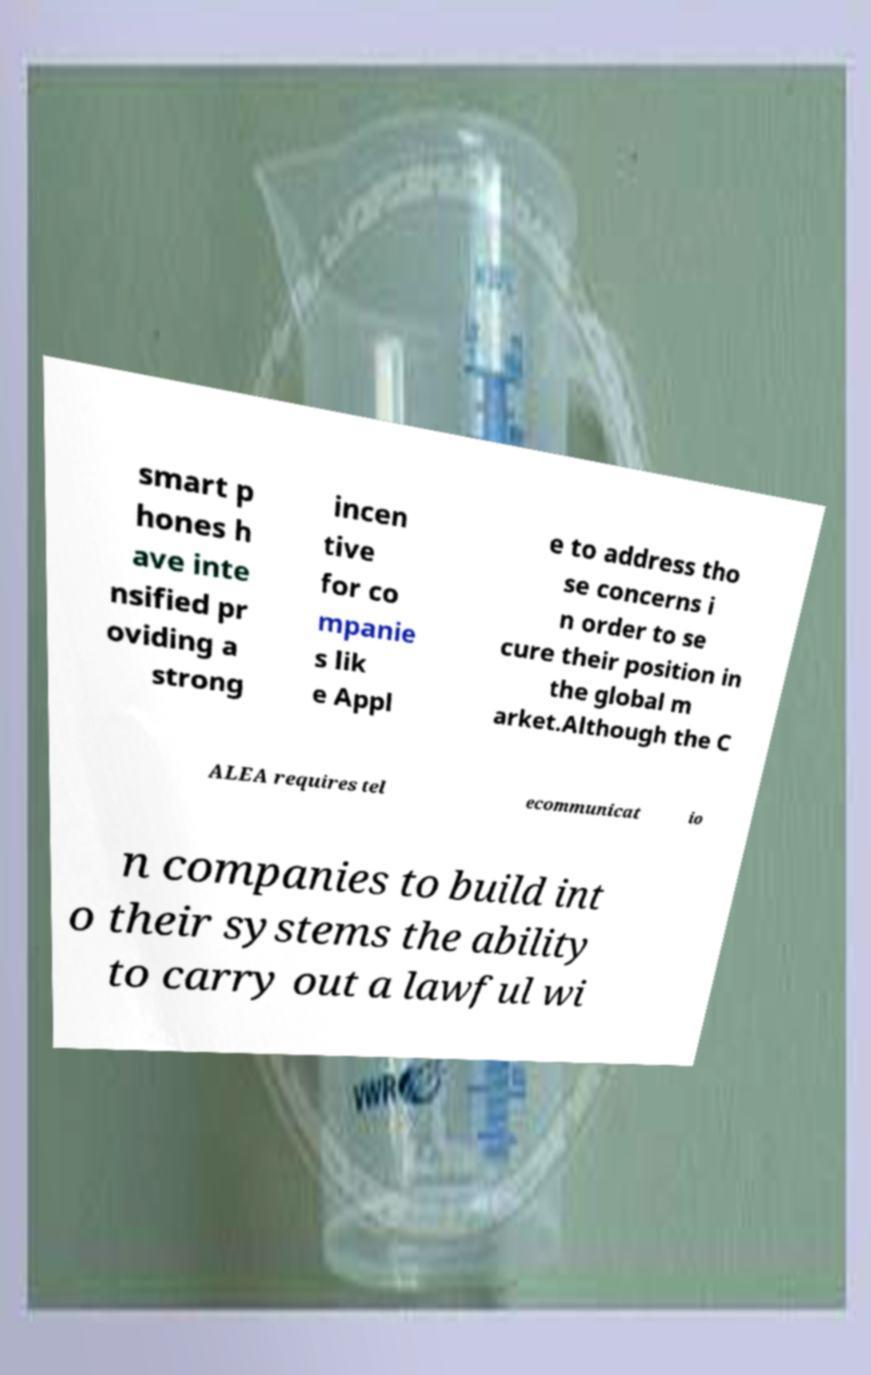Can you read and provide the text displayed in the image?This photo seems to have some interesting text. Can you extract and type it out for me? smart p hones h ave inte nsified pr oviding a strong incen tive for co mpanie s lik e Appl e to address tho se concerns i n order to se cure their position in the global m arket.Although the C ALEA requires tel ecommunicat io n companies to build int o their systems the ability to carry out a lawful wi 